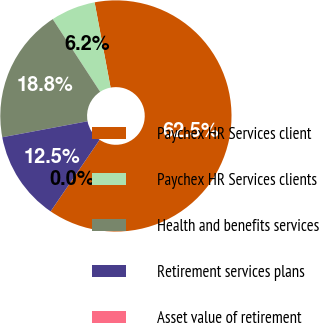Convert chart. <chart><loc_0><loc_0><loc_500><loc_500><pie_chart><fcel>Paychex HR Services client<fcel>Paychex HR Services clients<fcel>Health and benefits services<fcel>Retirement services plans<fcel>Asset value of retirement<nl><fcel>62.5%<fcel>6.25%<fcel>18.75%<fcel>12.5%<fcel>0.0%<nl></chart> 